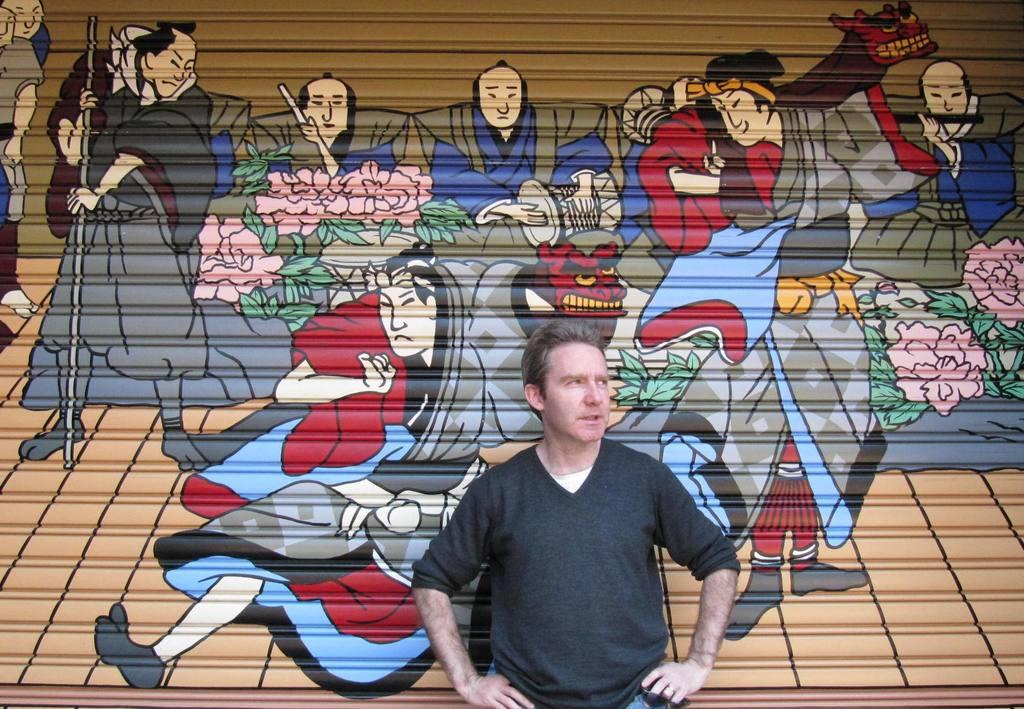Who is present in the image? There is a man in the image. What is the man wearing? The man is wearing a black t-shirt. Where is the man standing? The man is standing in front of a wall. What can be seen on the wall? There is a painting on the wall. Can you see a boat in the image? No, there is no boat present in the image. What type of work is the man doing in the image? The image does not show the man doing any work, so it cannot be determined from the image. 